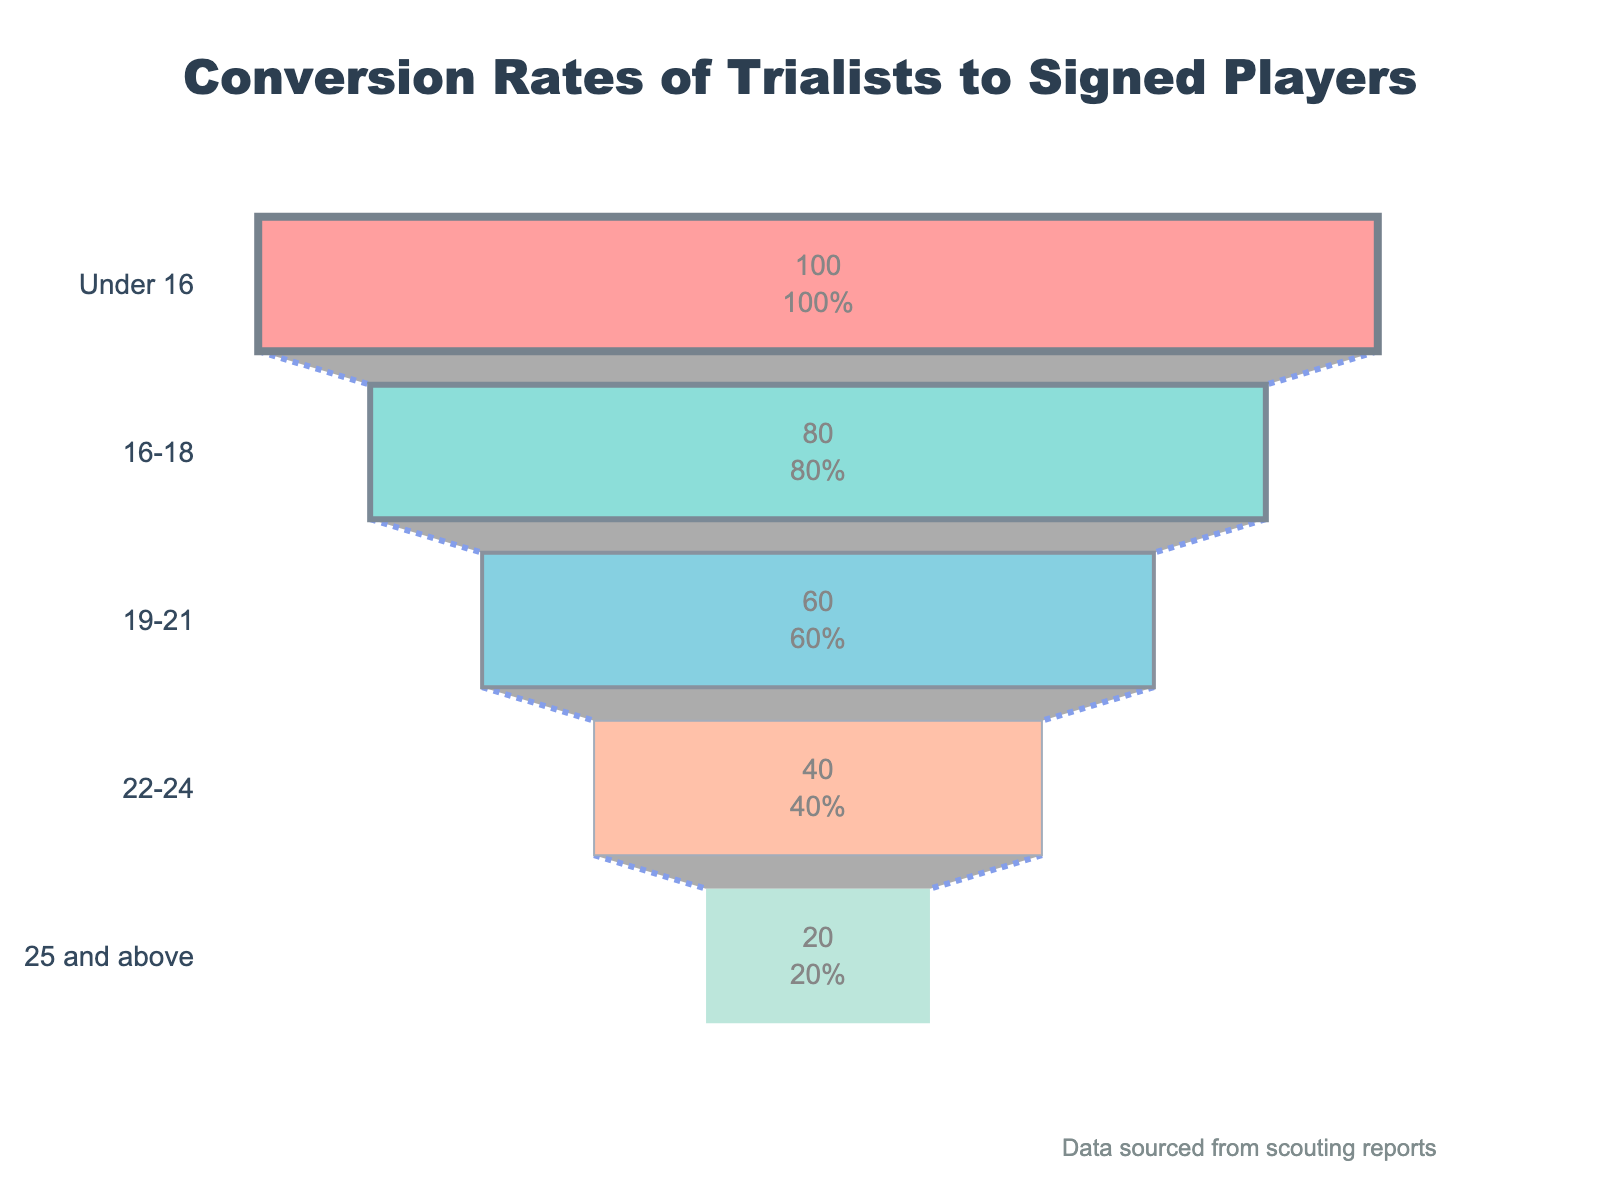Which age group has the highest conversion rate? By looking at the conversion rates in the funnel, identify the age group with the highest percentage. The highest conversion rate is 25% in the 19-21 age group.
Answer: 19-21 What is the total number of trialists from all age groups combined? Add up the number of trialists for all age groups: 100 + 80 + 60 + 40 + 20 = 300.
Answer: 300 Which age group has the lowest number of signed players, and how many are there? Locate the age group with the smallest signed players number, which is the 25 and above group with 2 signed players.
Answer: 25 and above, 2 How many more signed players are there in the 19-21 age group compared to the 25 and above age group? Compute the difference in signed players between the 19-21 group (15) and the 25 and above group (2): 15 - 2 = 13.
Answer: 13 What percentage of trialists were signed in the 16-18 age group? The conversion rate for the 16-18 age group is given as 15%.
Answer: 15% Which color represents the Under 16 age group in the funnel chart? The color for the Under 16 age group can be identified from the chart's color coding. It is the first segment colored in red.
Answer: Red Compare the conversion rate of the 16-18 age group with the 22-24 age group. Which is higher and by how much? The conversion rate for 16-18 is 15%, and for 22-24 is 20%. Difference = 20% - 15% = 5%.
Answer: 22-24, by 5% How many total signed players are there across all age groups combined? Sum up the number of signed players for each group: 8 + 12 + 15 + 8 + 2 = 45.
Answer: 45 What is the average conversion rate across all age groups? Conversion rates are 8%, 15%, 25%, 20%, 10%. Average = (8 + 15 + 25 + 20 + 10) / 5 = 15.6%.
Answer: 15.6% Is there an age group with a 0% conversion rate? Check each age group's conversion rate in the plot. None have a 0% conversion rate.
Answer: No 